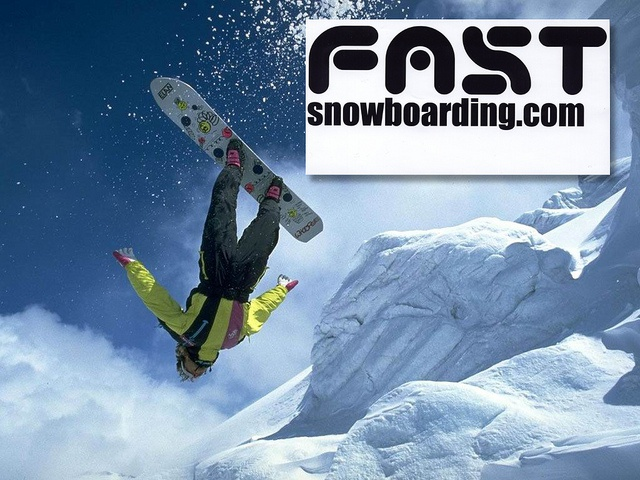Describe the objects in this image and their specific colors. I can see people in navy, black, gray, olive, and blue tones and snowboard in navy, gray, black, and blue tones in this image. 